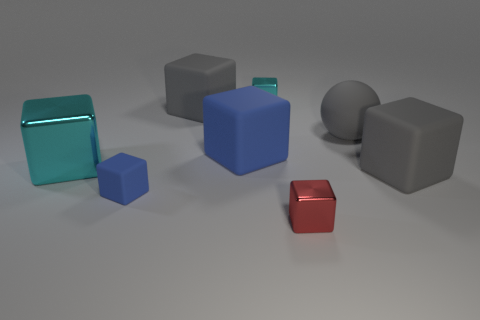There is another rubber cube that is the same color as the small rubber cube; what size is it?
Offer a terse response. Large. What number of large objects are either gray cubes or green metallic cylinders?
Your answer should be compact. 2. What material is the gray thing that is left of the cyan metallic thing behind the gray object behind the gray rubber sphere made of?
Your answer should be compact. Rubber. What number of metallic objects are either spheres or big cyan cubes?
Your answer should be very brief. 1. How many blue things are either small rubber things or metallic blocks?
Make the answer very short. 1. There is a small metallic object behind the large cyan metallic thing; is it the same color as the big metal cube?
Your answer should be compact. Yes. Is the small blue block made of the same material as the tiny red thing?
Give a very brief answer. No. Are there the same number of big blocks in front of the small matte cube and small cyan metallic cubes that are in front of the big cyan thing?
Your answer should be compact. Yes. There is another blue thing that is the same shape as the large blue rubber thing; what is it made of?
Make the answer very short. Rubber. There is a tiny shiny object behind the large gray rubber block on the right side of the tiny metallic thing behind the red cube; what shape is it?
Your answer should be very brief. Cube. 